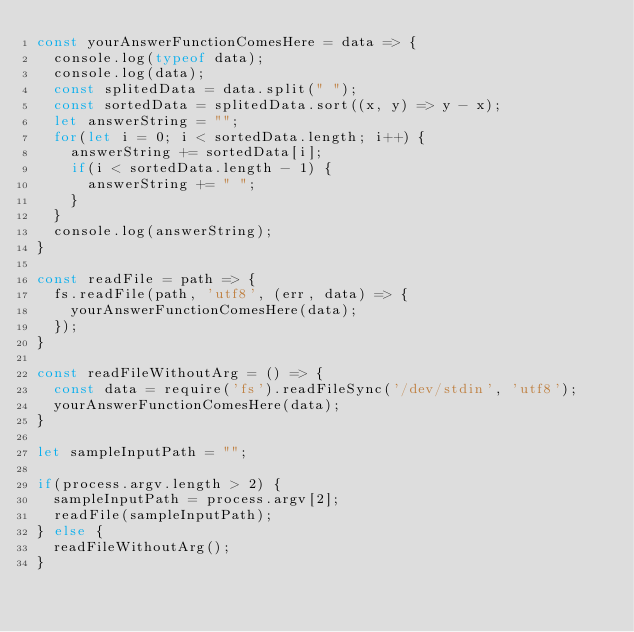<code> <loc_0><loc_0><loc_500><loc_500><_JavaScript_>const yourAnswerFunctionComesHere = data => {
  console.log(typeof data);
  console.log(data);
  const splitedData = data.split(" ");
  const sortedData = splitedData.sort((x, y) => y - x);
  let answerString = "";
  for(let i = 0; i < sortedData.length; i++) {
    answerString += sortedData[i];
    if(i < sortedData.length - 1) {
      answerString += " ";
    }
  }
  console.log(answerString);
}

const readFile = path => {
  fs.readFile(path, 'utf8', (err, data) => {
    yourAnswerFunctionComesHere(data);
  });
}

const readFileWithoutArg = () => {
  const data = require('fs').readFileSync('/dev/stdin', 'utf8');
  yourAnswerFunctionComesHere(data);
}

let sampleInputPath = "";

if(process.argv.length > 2) {
  sampleInputPath = process.argv[2];
  readFile(sampleInputPath);
} else {
  readFileWithoutArg();
}
</code> 